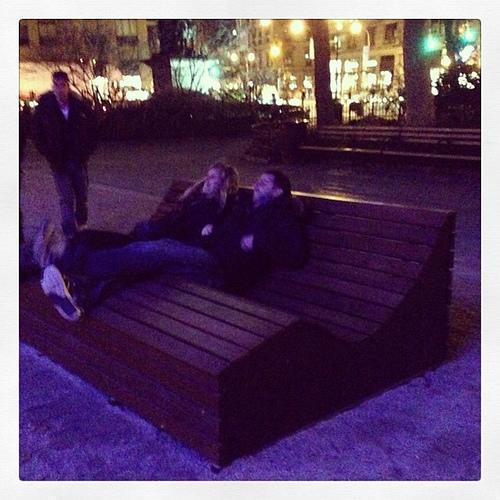How many people are laying?
Give a very brief answer. 2. 